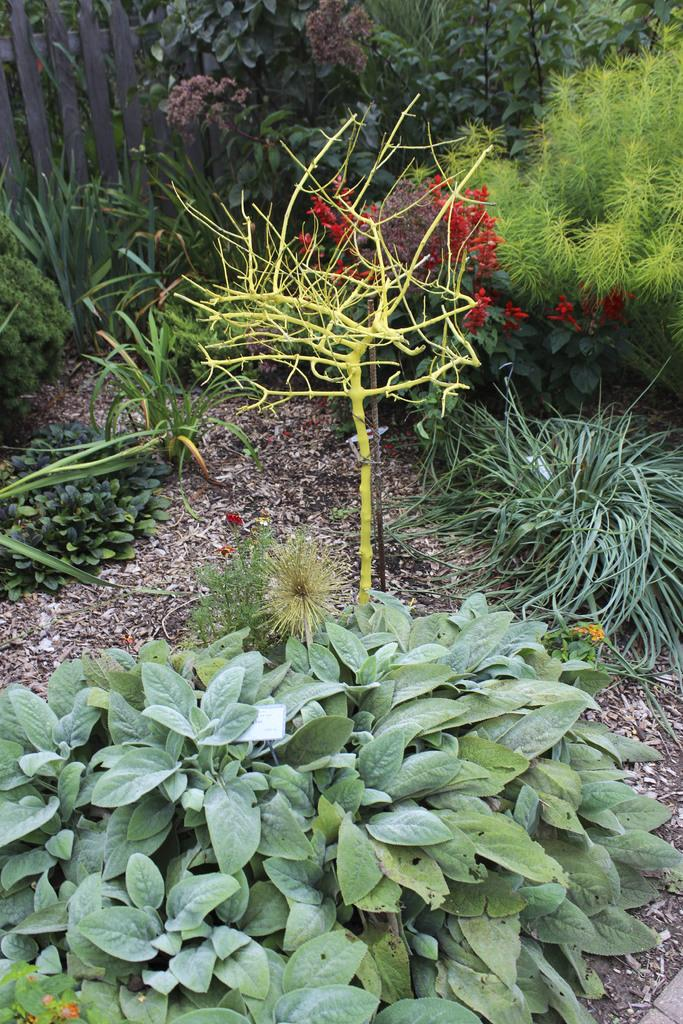What type of living organisms can be seen in the image? Plants can be seen in the image. What color are the plants in the image? The plants are green in color. What other elements can be seen in the background of the image? There are flowers in the background of the image. What color are the flowers in the image? The flowers are red in color. How does the muscle in the image help the goose fly? There is no goose or muscle present in the image; it features plants and flowers. 